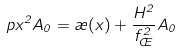Convert formula to latex. <formula><loc_0><loc_0><loc_500><loc_500>\ p x ^ { 2 } A _ { 0 } = \rho ( x ) + \frac { H ^ { 2 } } { f _ { \phi } ^ { 2 } } A _ { 0 }</formula> 